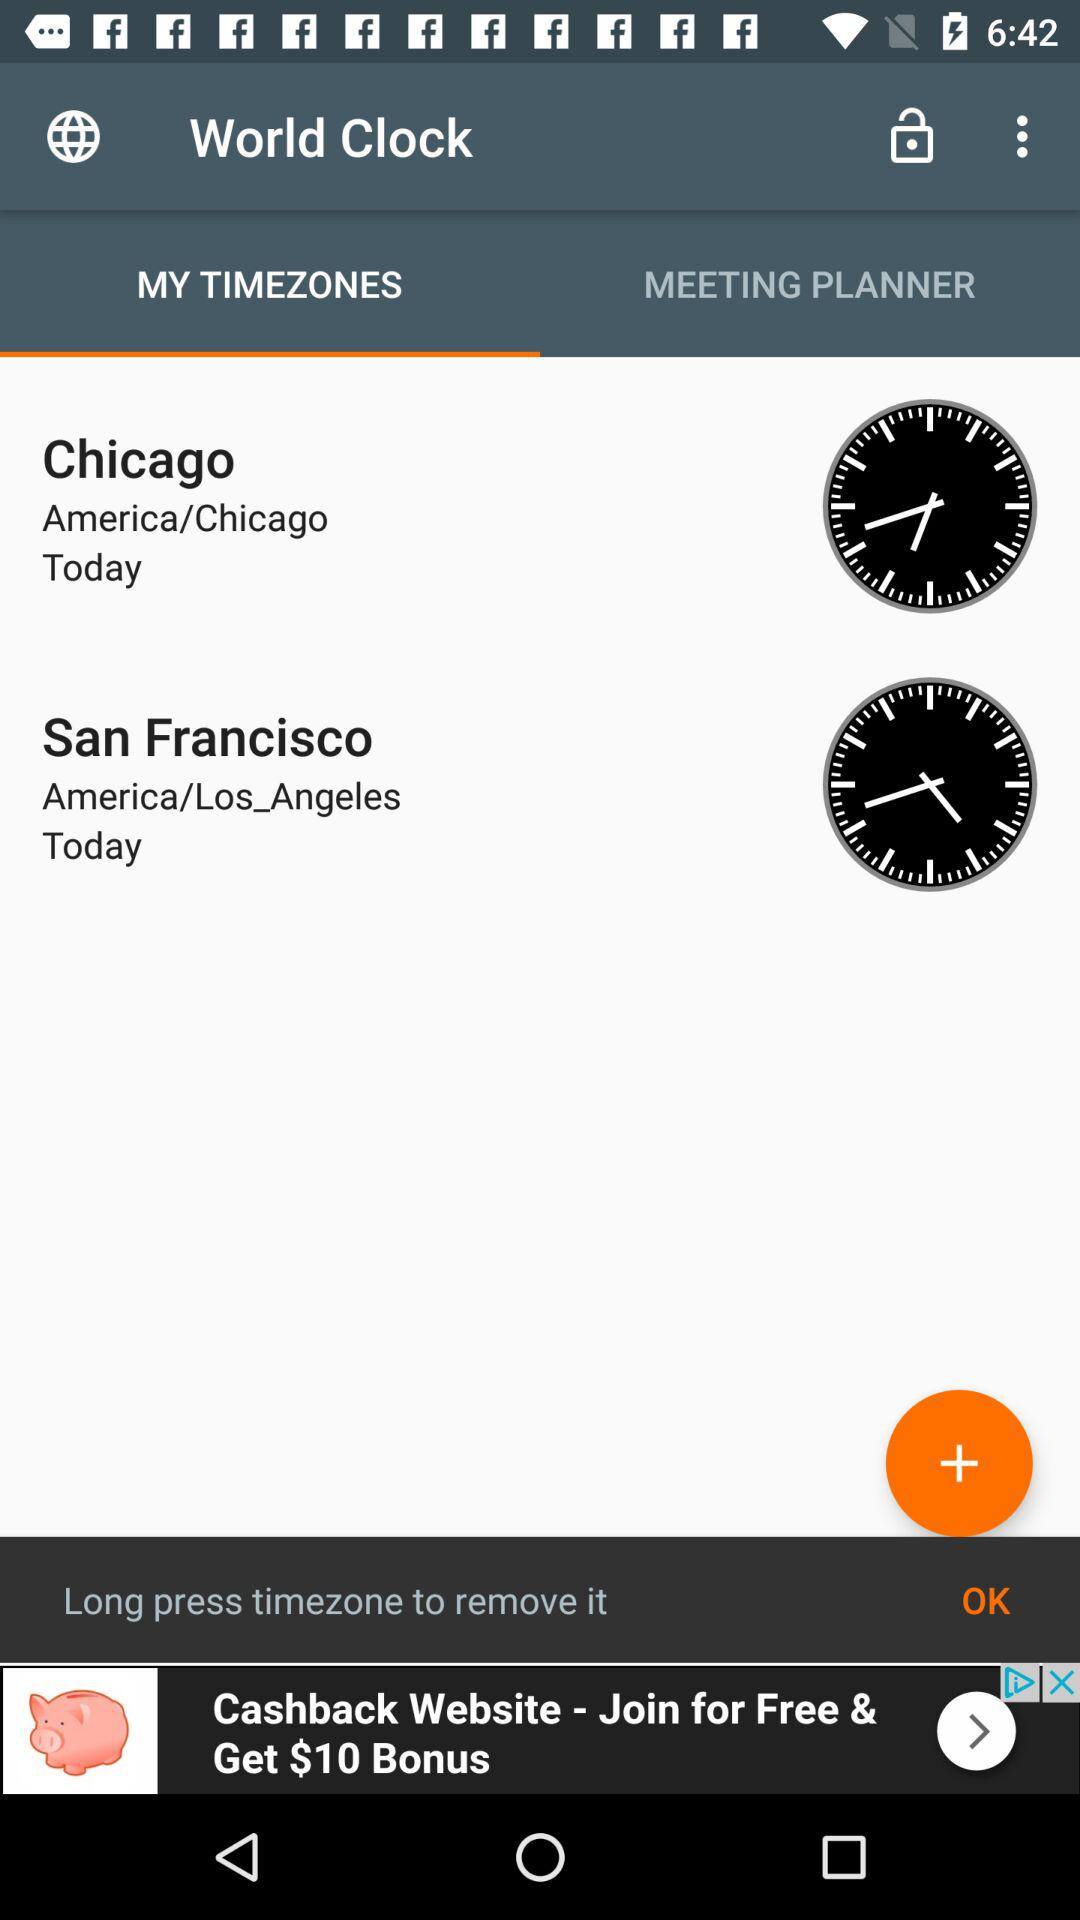Which tab are we on? You are on the "MY TIMEZONES" tab. 